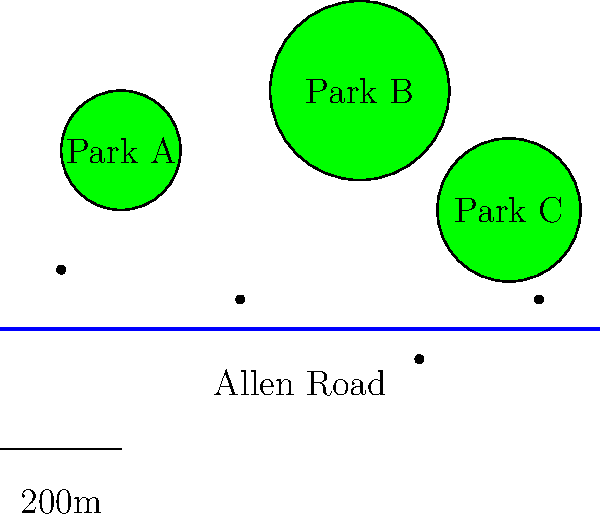Based on the map, which park is likely to serve the largest number of residents along Allen Road, and why? To determine which park is likely to serve the largest number of residents along Allen Road, we need to consider several factors:

1. Size of the park: Larger parks can accommodate more visitors.
2. Proximity to Allen Road: Parks closer to the road are more accessible to residents.
3. Central location: Parks in the middle of the residential area can serve people from both sides.

Let's analyze each park:

1. Park A:
   - Smallest in size
   - Close to Allen Road
   - Located at one end of the mapped area

2. Park B:
   - Largest in size
   - Furthest from Allen Road
   - Centrally located along the mapped area

3. Park C:
   - Medium size
   - Relatively close to Allen Road
   - Located towards the other end of the mapped area

Considering these factors, Park B is likely to serve the largest number of residents because:
- It has the largest area, allowing for more diverse activities and accommodating more visitors.
- Its central location makes it accessible to residents from both ends of Allen Road.
- Although it's the furthest from Allen Road, its size and central location outweigh this disadvantage.
Answer: Park B 